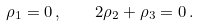Convert formula to latex. <formula><loc_0><loc_0><loc_500><loc_500>\rho _ { 1 } = 0 \, , \quad 2 \rho _ { 2 } + \rho _ { 3 } = 0 \, .</formula> 